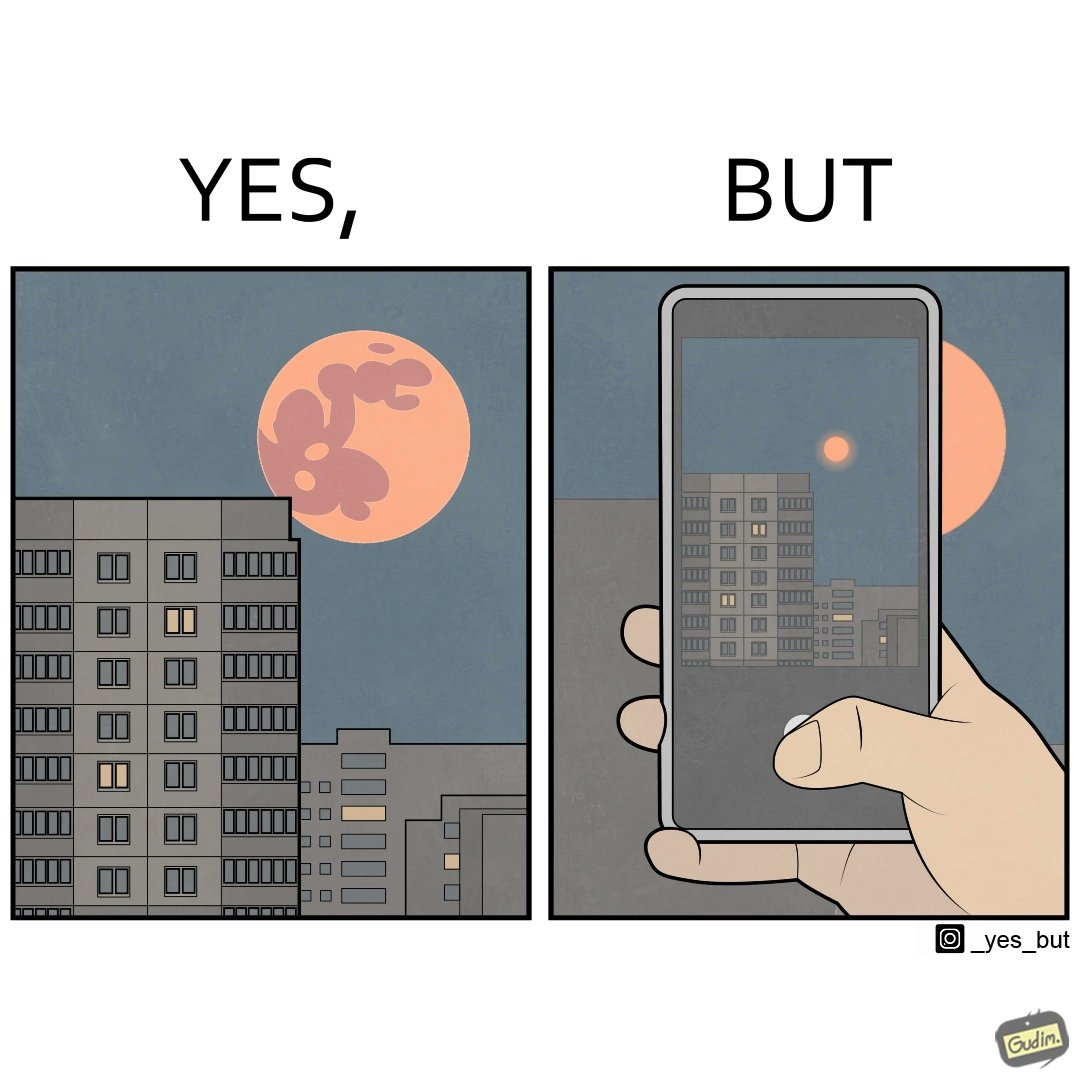Explain the humor or irony in this image. The image is ironic, because the phone is not able to capture the real beauty of the view which the viewer can see by their naked eyes 